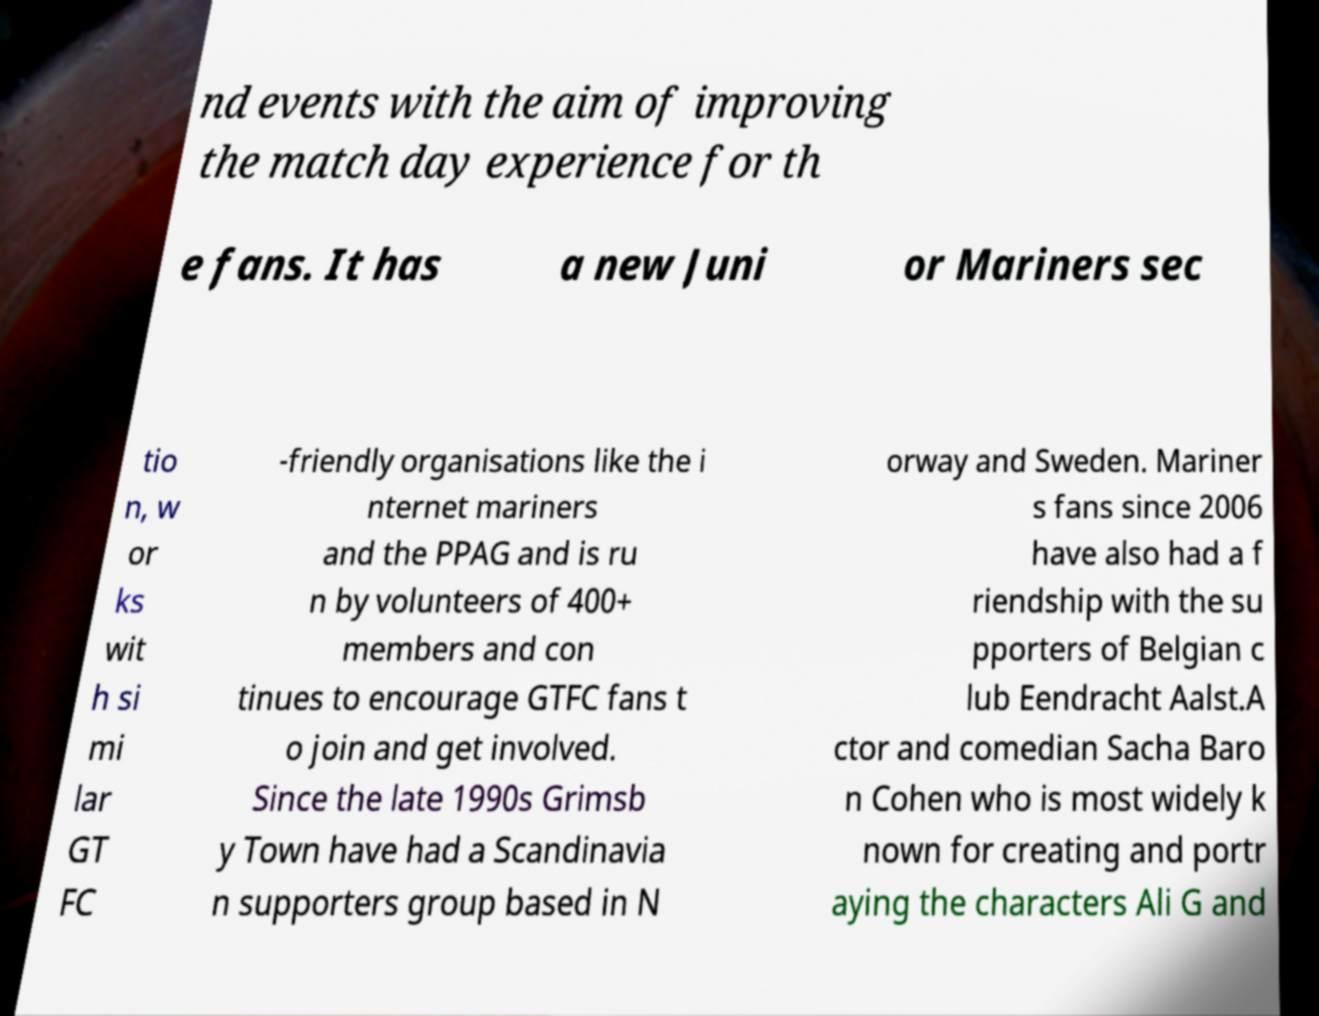I need the written content from this picture converted into text. Can you do that? nd events with the aim of improving the match day experience for th e fans. It has a new Juni or Mariners sec tio n, w or ks wit h si mi lar GT FC -friendly organisations like the i nternet mariners and the PPAG and is ru n by volunteers of 400+ members and con tinues to encourage GTFC fans t o join and get involved. Since the late 1990s Grimsb y Town have had a Scandinavia n supporters group based in N orway and Sweden. Mariner s fans since 2006 have also had a f riendship with the su pporters of Belgian c lub Eendracht Aalst.A ctor and comedian Sacha Baro n Cohen who is most widely k nown for creating and portr aying the characters Ali G and 